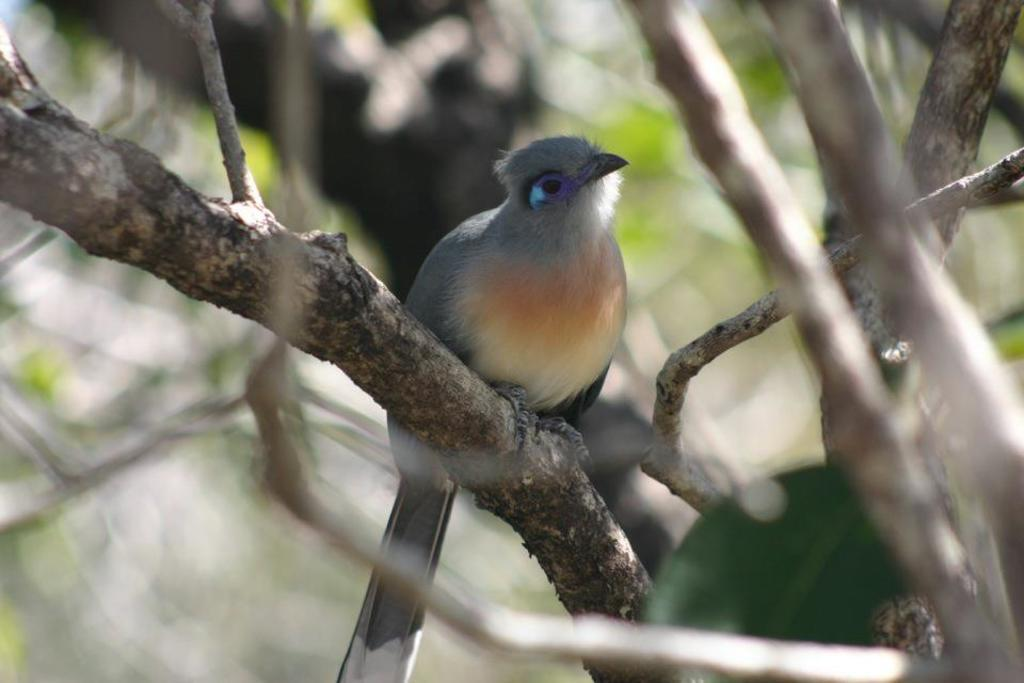What type of animal can be seen in the image? There is a bird in the image. Where is the bird located? The bird is on a branch in the image. What else can be seen in the image besides the bird? There are branches visible in the image. Can you describe the background of the image? The background of the image is blurred. What type of friction is the bird experiencing while on the branch? There is no information provided about the friction experienced by the bird in the image. 